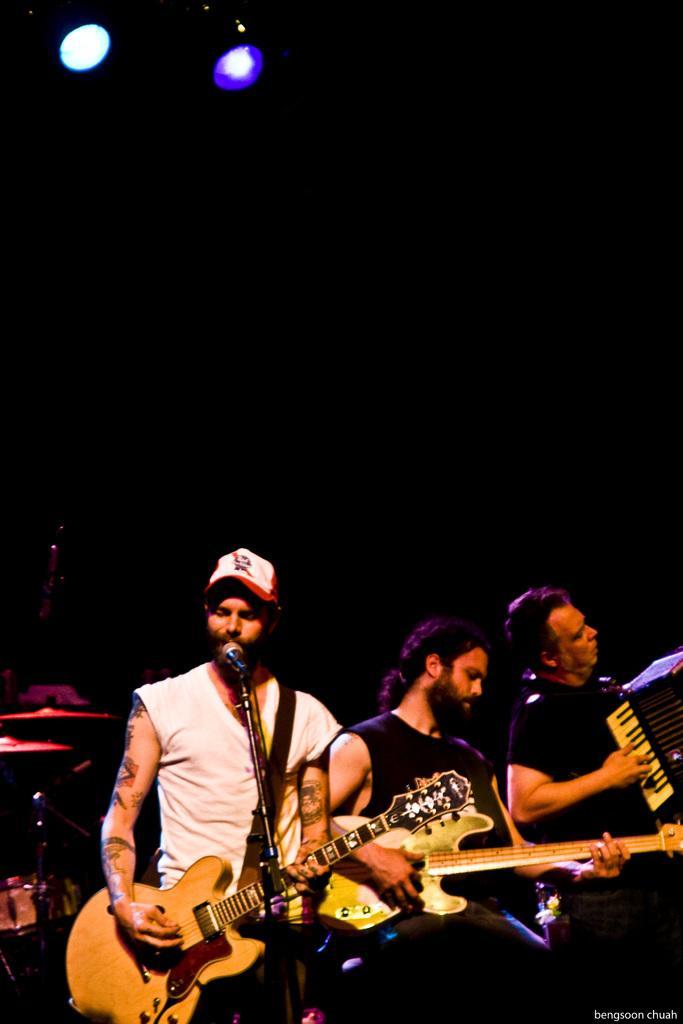Can you describe this image briefly? There are three men. The men with white t-shirt is singing and playing a guitar. In front of him there is a mic. The other man is also playing a guitar. The last right man is playing a piano. 